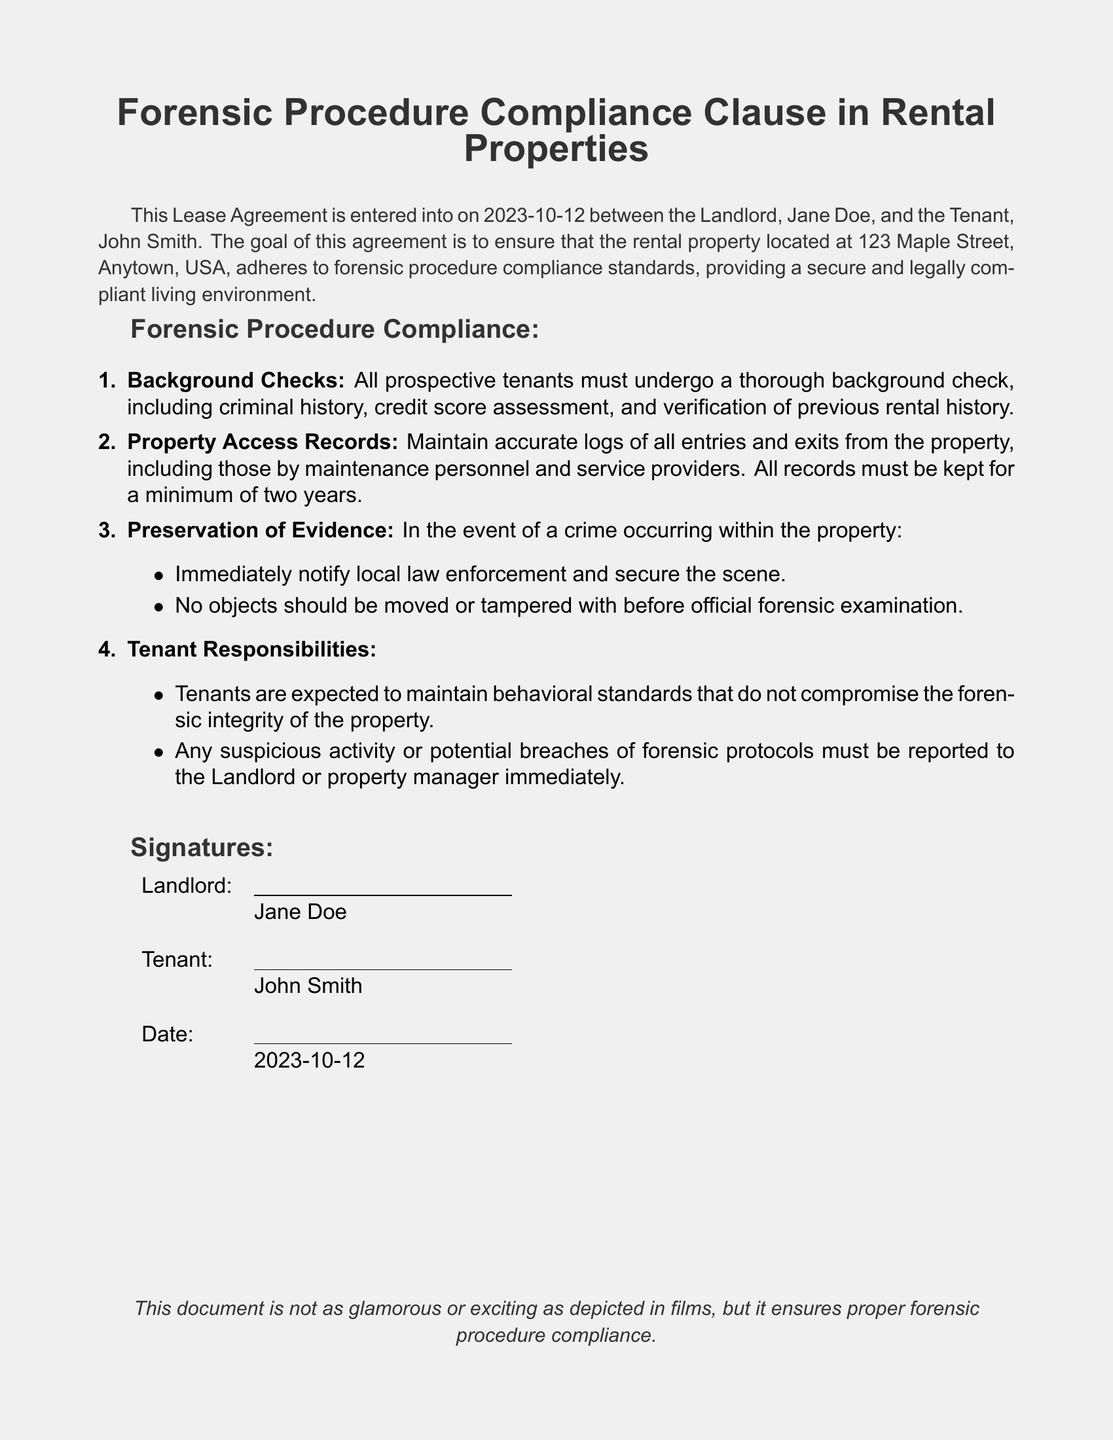What is the name of the landlord? The landlord is identified as Jane Doe in the document.
Answer: Jane Doe What is the name of the tenant? The tenant is identified as John Smith in the document.
Answer: John Smith What is the address of the rental property? The property address is specified in the document.
Answer: 123 Maple Street, Anytown, USA When was the lease agreement signed? The signing date is listed at the bottom of the document.
Answer: 2023-10-12 What is the minimum duration for maintaining property access records? The document states the required duration for keeping records.
Answer: two years What must tenants report immediately? The document specifies what tenants must communicate promptly.
Answer: suspicious activity or potential breaches of forensic protocols What should be done if a crime occurs at the property? The document outlines specific actions to take during a crime incident.
Answer: Notify local law enforcement and secure the scene What are tenants expected to maintain? The document indicates a particular standard tenants should uphold.
Answer: behavioral standards What must be preserved in the event of a crime? The document lists an item related to the integrity of the crime scene.
Answer: evidence 